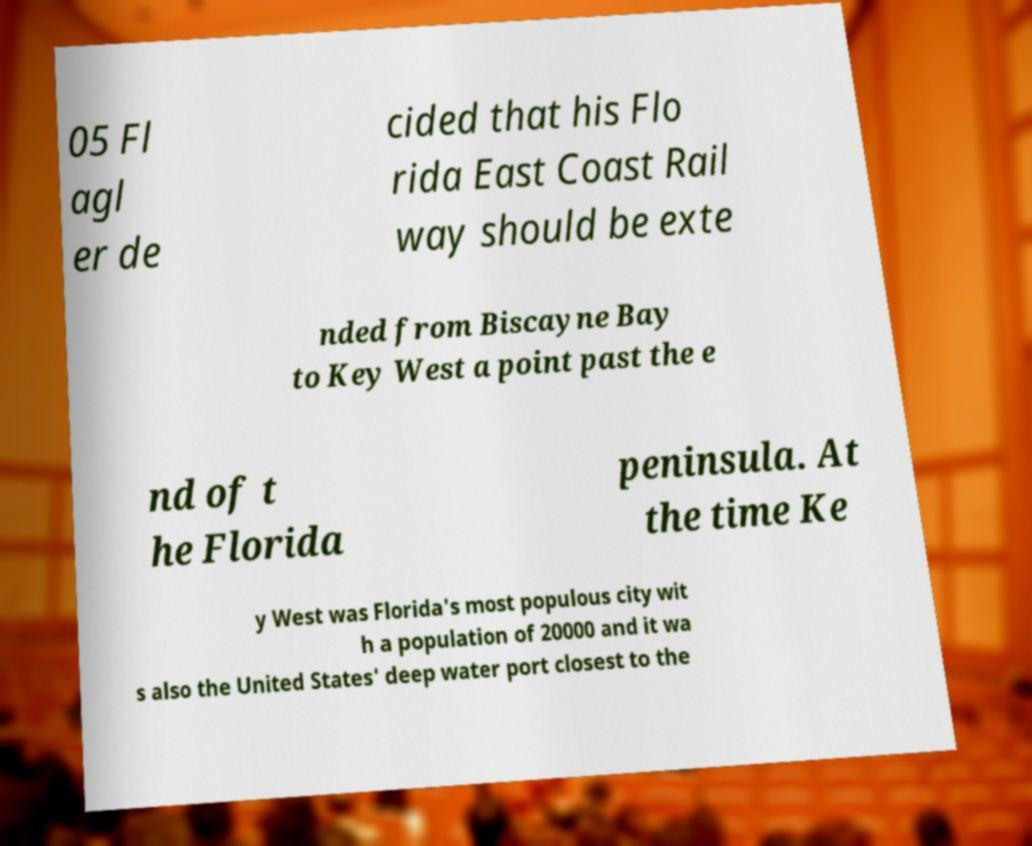Could you extract and type out the text from this image? 05 Fl agl er de cided that his Flo rida East Coast Rail way should be exte nded from Biscayne Bay to Key West a point past the e nd of t he Florida peninsula. At the time Ke y West was Florida's most populous city wit h a population of 20000 and it wa s also the United States' deep water port closest to the 